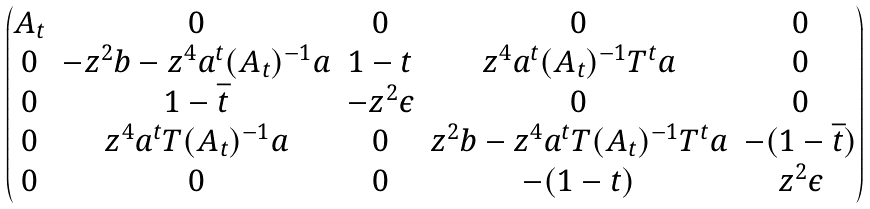<formula> <loc_0><loc_0><loc_500><loc_500>\begin{pmatrix} A _ { t } & 0 & 0 & 0 & 0 \\ 0 & - z ^ { 2 } b - z ^ { 4 } a ^ { t } ( A _ { t } ) ^ { - 1 } a & 1 - t & z ^ { 4 } a ^ { t } ( A _ { t } ) ^ { - 1 } T ^ { t } a & 0 \\ 0 & 1 - \bar { t } & - z ^ { 2 } \epsilon & 0 & 0 \\ 0 & z ^ { 4 } a ^ { t } T ( A _ { t } ) ^ { - 1 } a & 0 & z ^ { 2 } b - z ^ { 4 } a ^ { t } T ( A _ { t } ) ^ { - 1 } T ^ { t } a & - ( 1 - \bar { t } ) \\ 0 & 0 & 0 & - ( 1 - t ) & z ^ { 2 } \epsilon \end{pmatrix}</formula> 